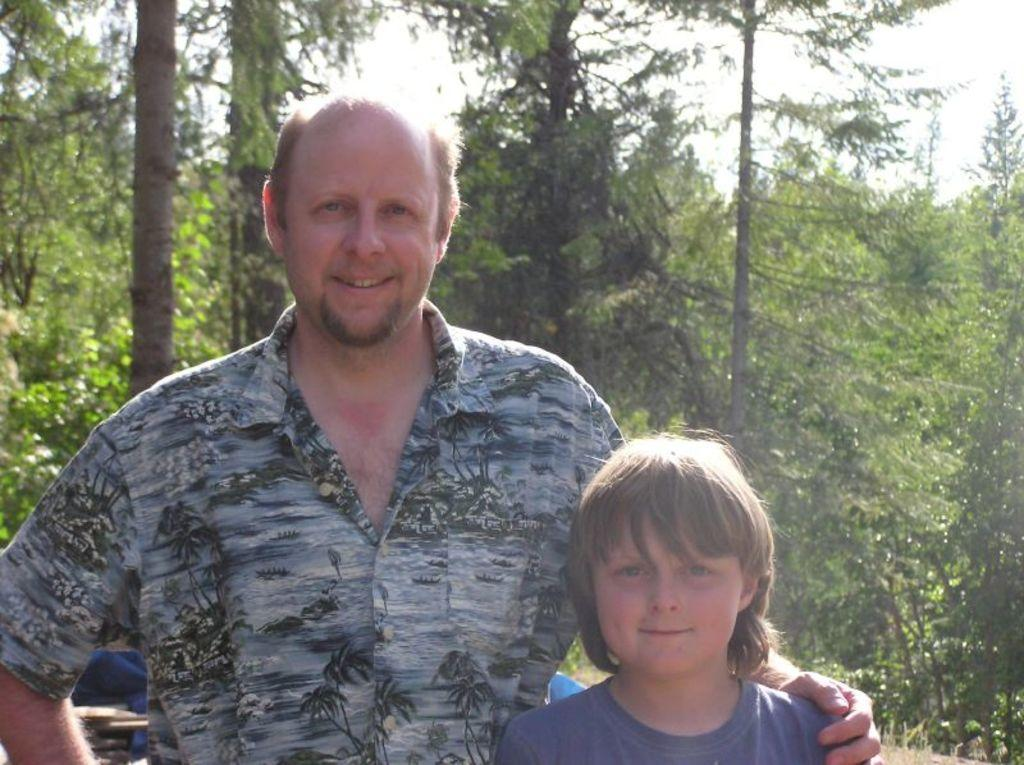Who is present in the image? There is a man and a child in the image. What are the man and child doing in the image? The man and child are standing. What can be seen in the background of the image? There are trees and the sky visible in the background of the image. What type of insurance policy is the man discussing with the child in the image? There is no indication in the image that the man and child are discussing insurance or any other topic. 